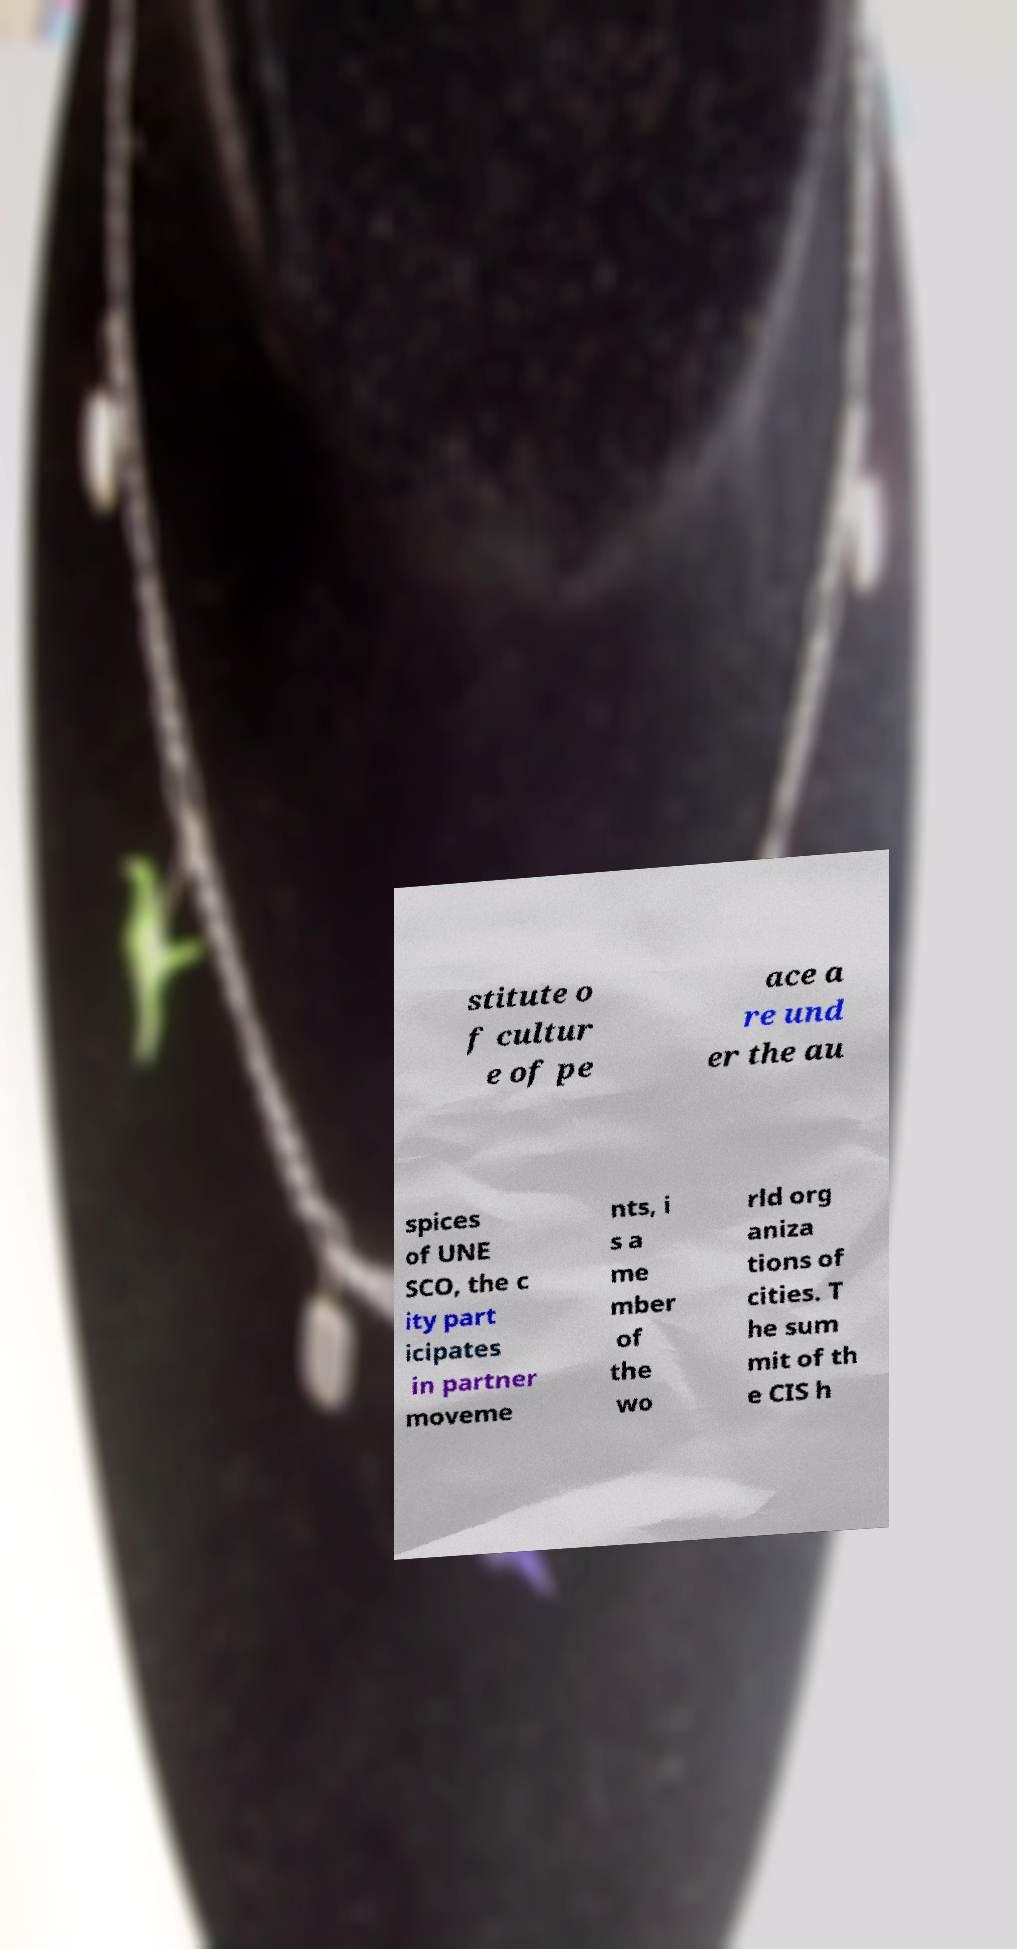Please read and relay the text visible in this image. What does it say? stitute o f cultur e of pe ace a re und er the au spices of UNE SCO, the c ity part icipates in partner moveme nts, i s a me mber of the wo rld org aniza tions of cities. T he sum mit of th e CIS h 